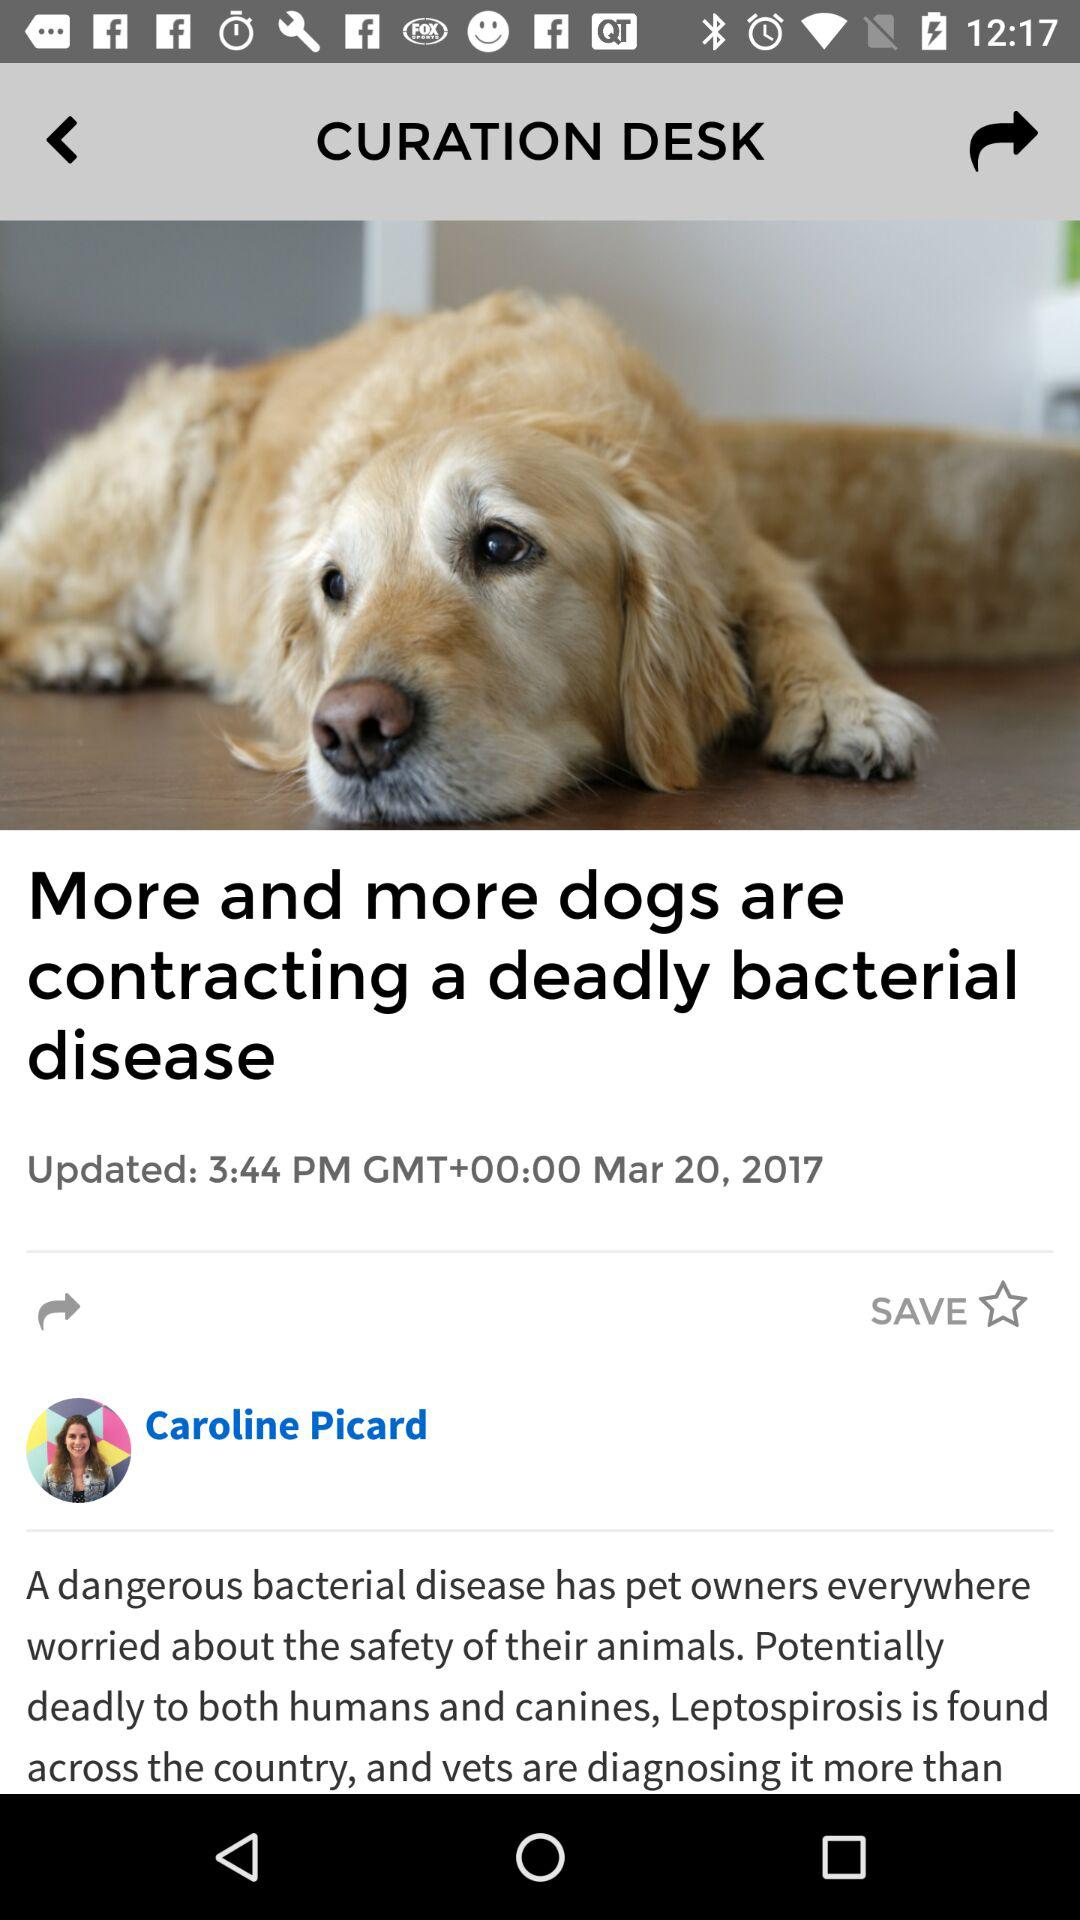What is the date when the article was posted? The article was posted on March 20, 2017. 